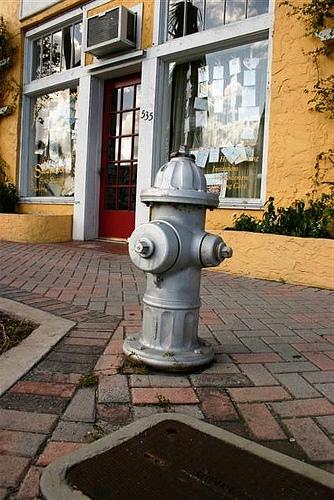Does the ground appear wet?
Concise answer only. No. What do the numbers next to the door mean?
Be succinct. Address. Is this a fire hydrant?
Concise answer only. Yes. What color is the door?
Short answer required. Red. What is the sidewalk lined with in the background?
Answer briefly. Brick. 